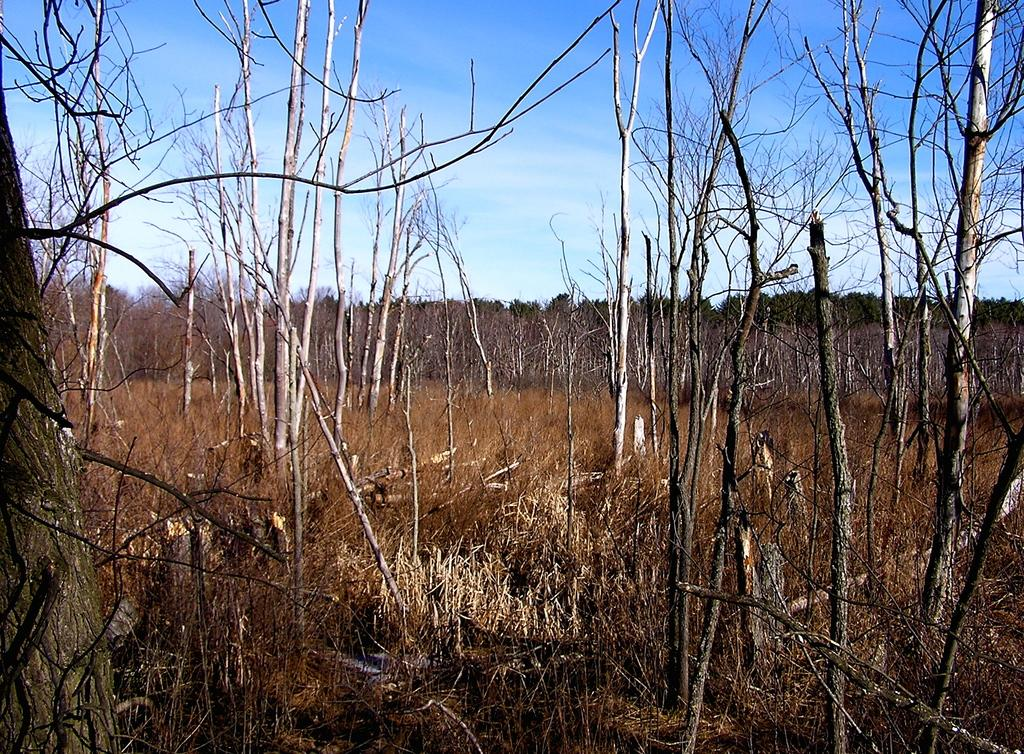What type of vegetation can be seen in the image? There are trees in the image. What is covering the ground in the image? There is grass on the ground in the image. How would you describe the sky in the image? The sky is blue and cloudy in the image. Can you see the partner holding a rose near the sea in the image? There is no partner, rose, or sea present in the image; it features trees, grass, and a blue, cloudy sky. 